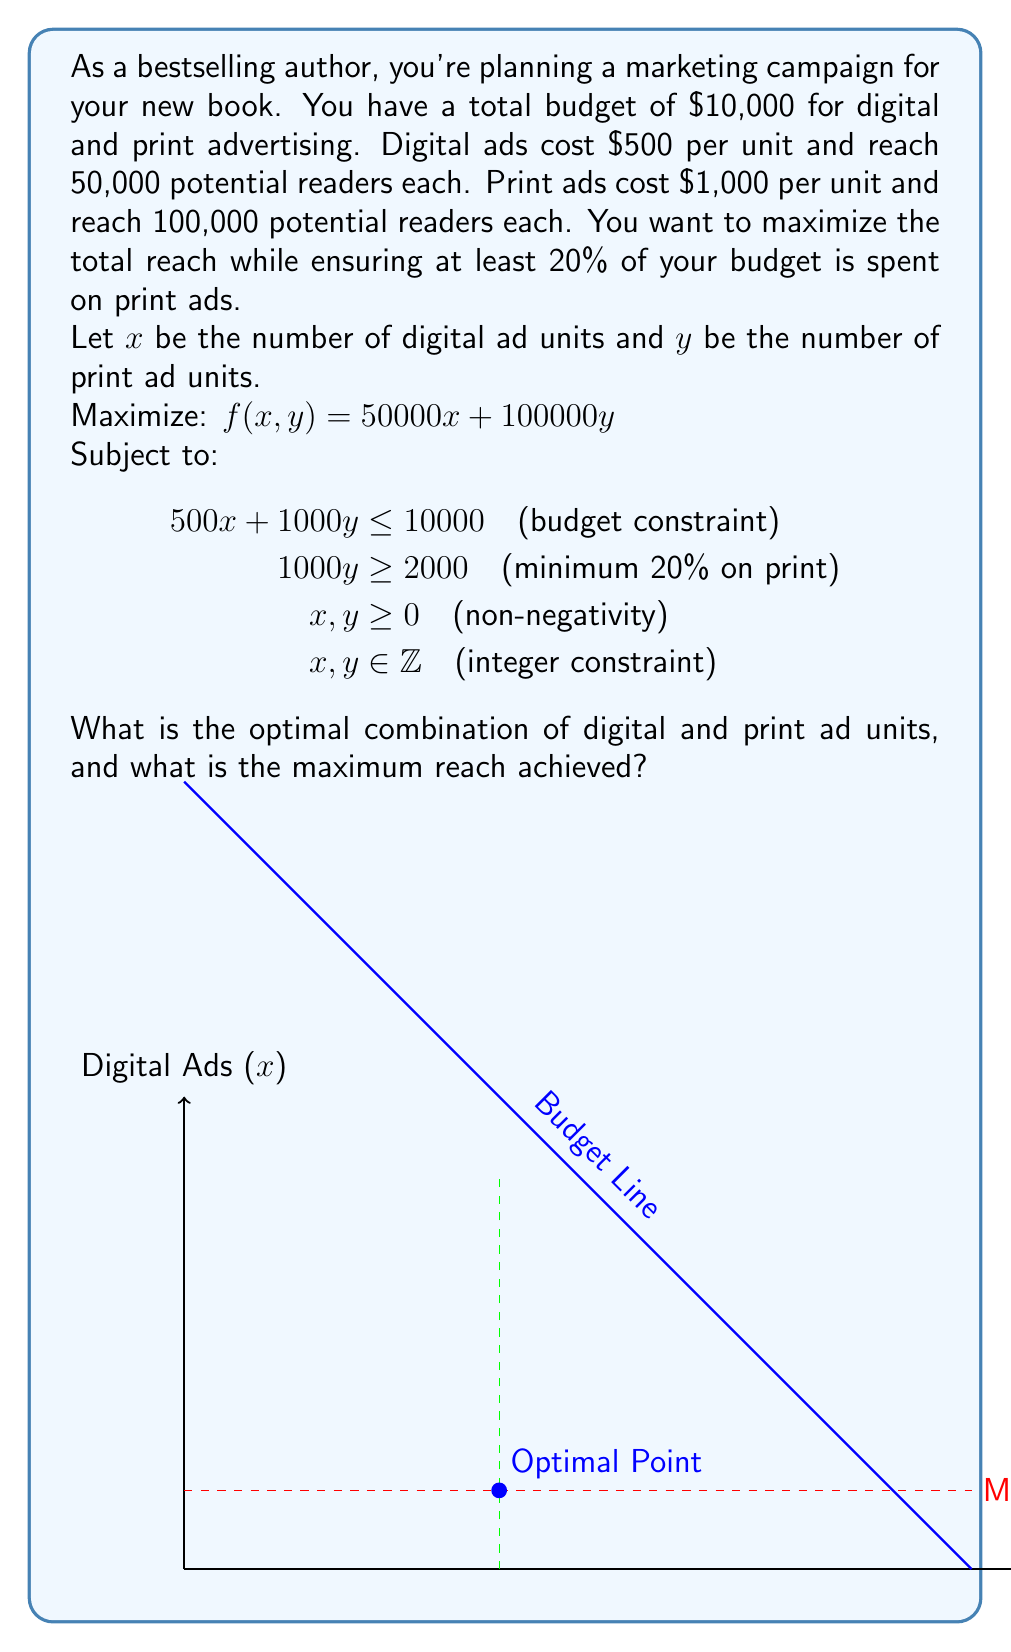Can you answer this question? Let's approach this step-by-step:

1) First, we need to set up our constraints:
   - Budget constraint: $500x + 1000y \leq 10000$
   - Minimum print ad constraint: $1000y \geq 2000$ or $y \geq 2$
   - Non-negativity: $x \geq 0, y \geq 0$
   - Integer constraint: $x, y \in \mathbb{Z}$

2) We want to maximize $f(x,y) = 50000x + 100000y$

3) From the budget constraint, we can derive:
   $500x + 1000y = 10000$
   $x = 20 - 2y$

4) Substituting this into our objective function:
   $f(y) = 50000(20-2y) + 100000y = 1000000 - 100000y + 100000y = 1000000$

5) This means that any combination of $x$ and $y$ that satisfies the budget constraint will give the same reach. We just need to find the feasible integer solution that satisfies all constraints.

6) Given $y \geq 2$ (minimum print ad constraint), let's start with $y = 2$:
   If $y = 2$, then $x = 20 - 2(2) = 16$

7) Check if this satisfies all constraints:
   - Budget: $500(16) + 1000(2) = 10000$ (✓)
   - Minimum print: $2 \geq 2$ (✓)
   - Non-negativity: $16 \geq 0, 2 \geq 0$ (✓)
   - Integer: $16, 2 \in \mathbb{Z}$ (✓)

8) Calculate the reach: $50000(16) + 100000(2) = 1000000$

Therefore, the optimal solution is 16 digital ad units and 2 print ad units.
Answer: 16 digital ad units, 2 print ad units; maximum reach of 1,000,000 potential readers. 